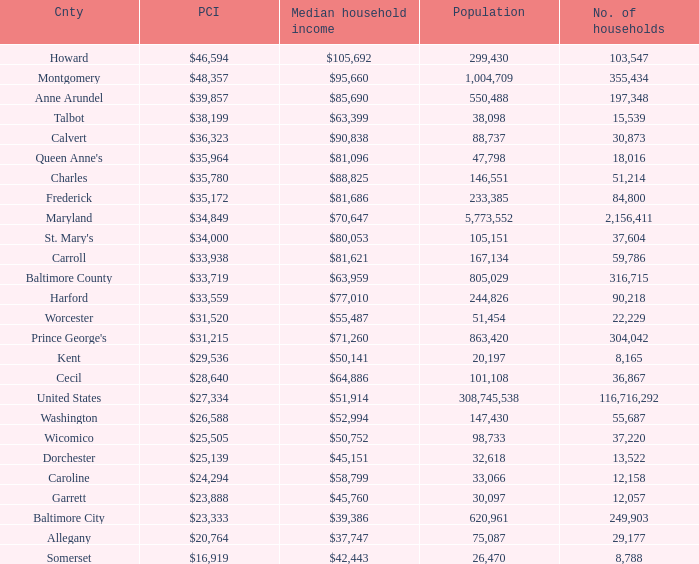What is the per capital income for Charles county? $35,780. 